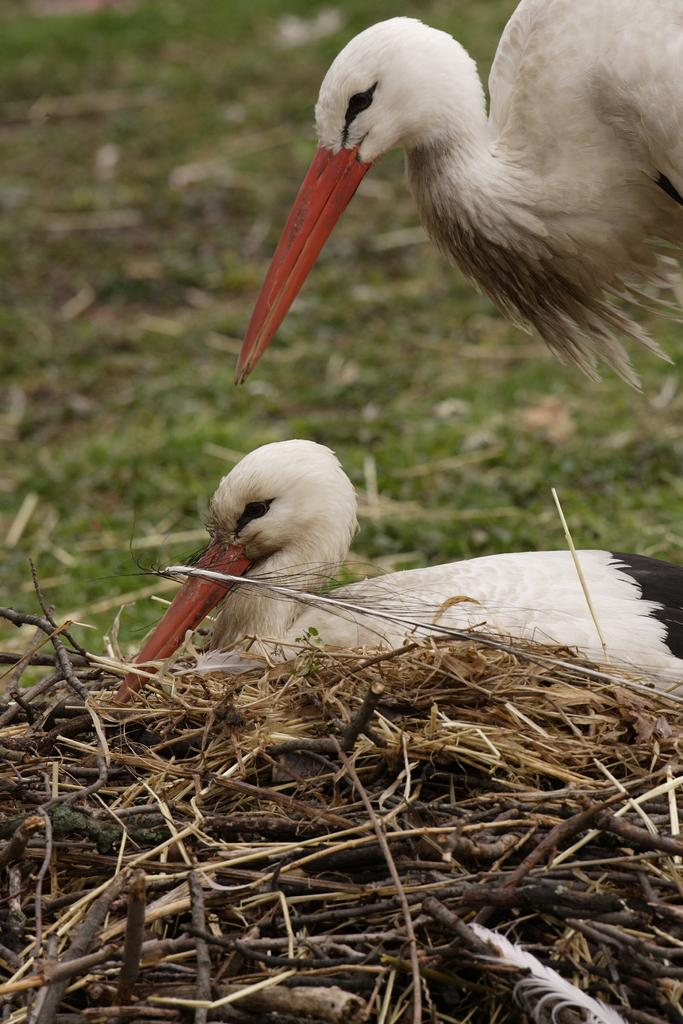What type of animals can be seen in the image? There are two white-colored birds in the image. What can be seen in the background of the image? There is grass visible in the background of the image. What structure is present in the image? There is a nest in the image. How is the image's quality in the background? The image is slightly blurry in the background. Can you see any ice in the image? There is no ice present in the image. What color are the crayons in the image? There are no crayons present in the image. 